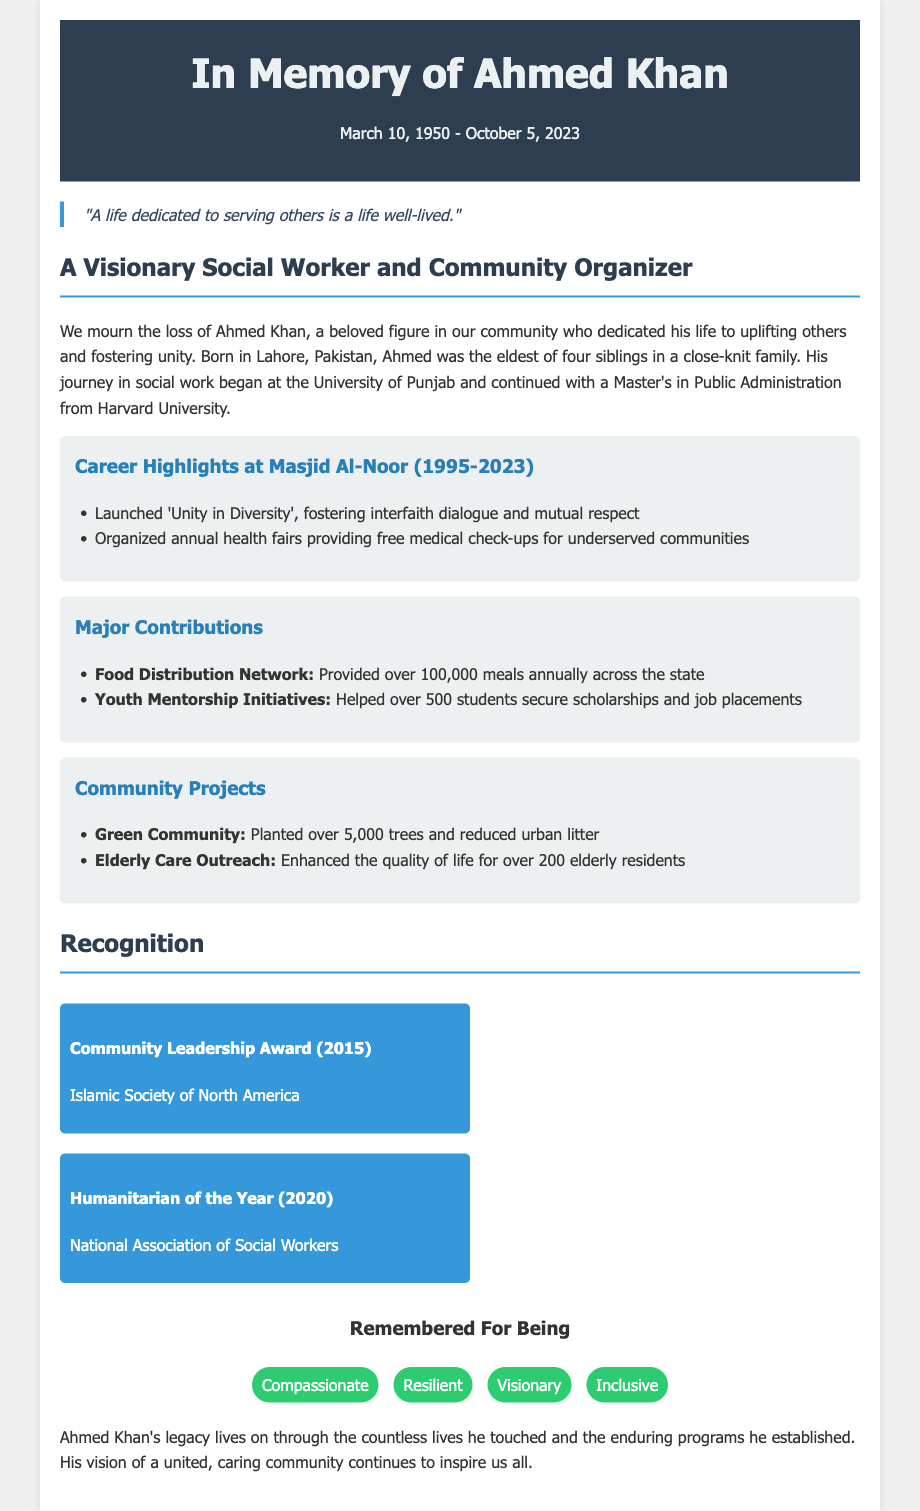What was Ahmed Khan's date of birth? Ahmed Khan was born on March 10, 1950, as mentioned in the obituary.
Answer: March 10, 1950 What is the title of the community initiative launched by Ahmed Khan? The initiative launched by Ahmed Khan is titled 'Unity in Diversity'.
Answer: Unity in Diversity How many meals did the Food Distribution Network provide annually? The Food Distribution Network provided over 100,000 meals annually, as specified in the document.
Answer: 100,000 meals What award did Ahmed Khan receive in 2015? In 2015, Ahmed Khan received the Community Leadership Award, as highlighted in the recognition section.
Answer: Community Leadership Award How many trees were planted in the Green Community project? The Green Community project resulted in the planting of over 5,000 trees, according to the community projects section.
Answer: 5,000 trees Which organization awarded Ahmed Khan the Humanitarian of the Year in 2020? The National Association of Social Workers awarded Ahmed Khan as the Humanitarian of the Year in 2020.
Answer: National Association of Social Workers What quality is Ahmed Khan remembered for being? Ahmed Khan is remembered for being compassionate, resilient, visionary, and inclusive, as listed in the personal qualities section.
Answer: Compassionate What was Ahmed Khan's educational background? He obtained a Master's in Public Administration from Harvard University, as stated in the document.
Answer: Master's in Public Administration from Harvard University 